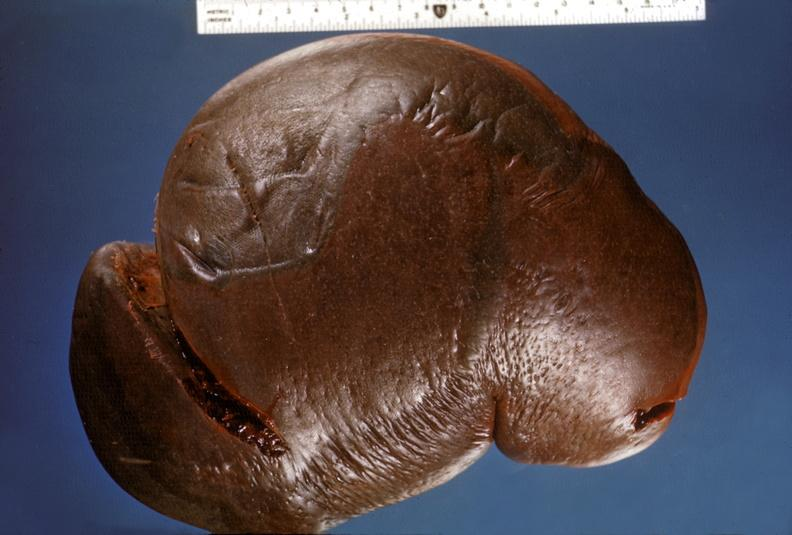does wound show spleen, hypersplenism?
Answer the question using a single word or phrase. No 